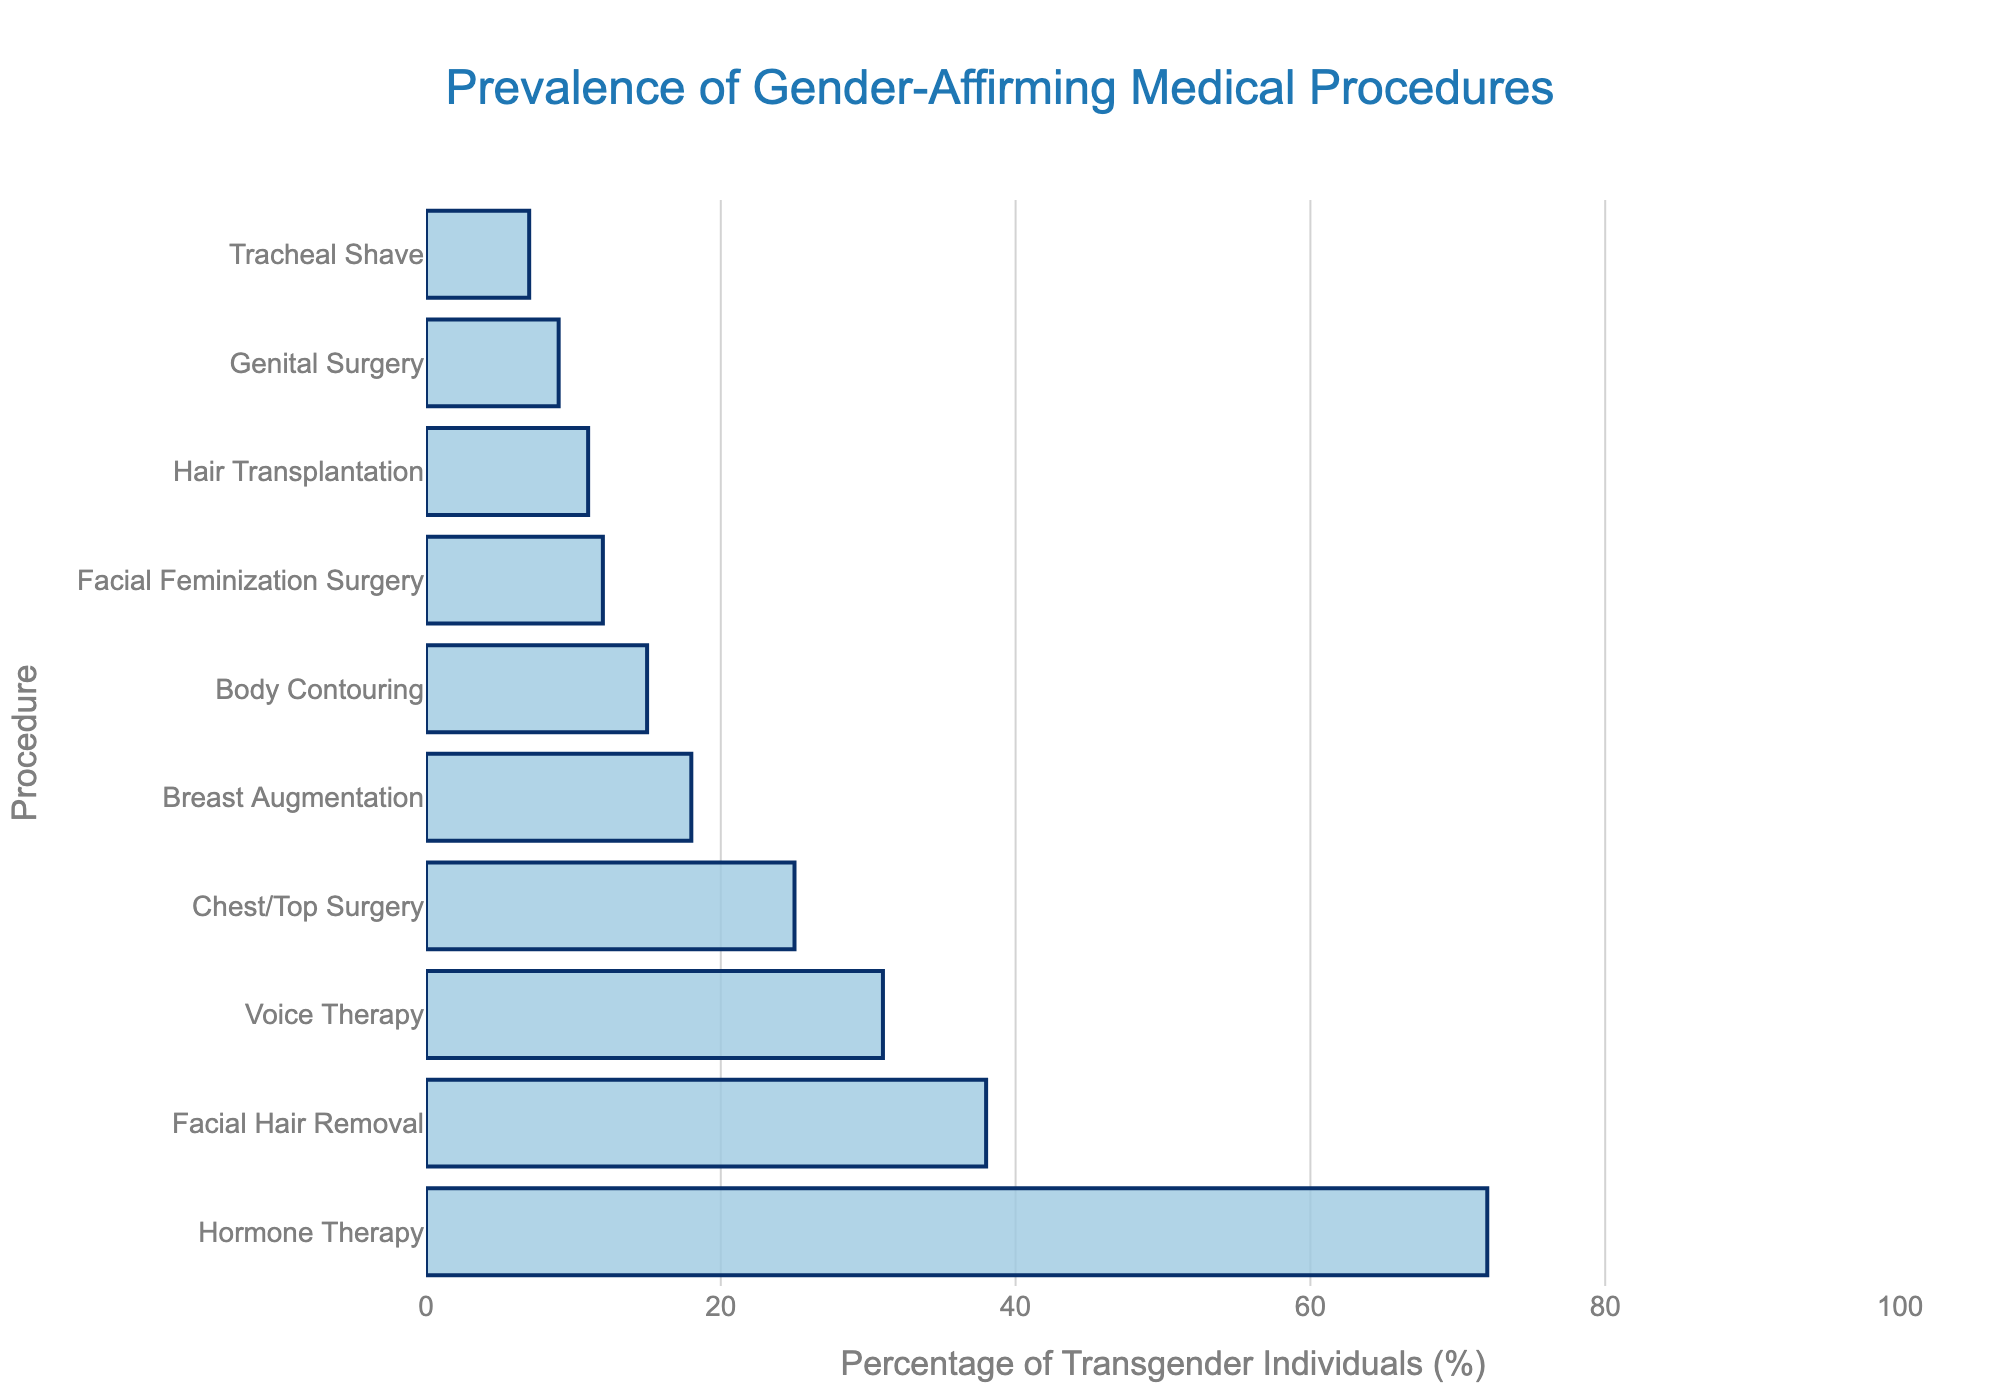What is the most common gender-affirming medical procedure according to the chart? The chart shows bars representing the percentage of transgender individuals undergoing various procedures. The longest bar represents the most common procedure. The longest bar belongs to Hormone Therapy at 72%.
Answer: Hormone Therapy Which procedure has a lower prevalence: Chest/Top Surgery or Breast Augmentation? By comparing the lengths of the bars representing Chest/Top Surgery and Breast Augmentation, Chest/Top Surgery is 25% and Breast Augmentation is 18%, so Breast Augmentation has a lower prevalence.
Answer: Breast Augmentation What is the combined percentage of transgender individuals who have undergone Facial Hair Removal and Voice Therapy? Add the percentages for Facial Hair Removal and Voice Therapy. Facial Hair Removal is 38% and Voice Therapy is 31%. The combined percentage is 38% + 31% = 69%.
Answer: 69% Among Tracheal Shave, Body Contouring, and Hair Transplantation, which procedure is the least prevalent? Comparing the lengths of the bars for Tracheal Shave (7%), Body Contouring (15%), and Hair Transplantation (11%), Tracheal Shave is the least prevalent.
Answer: Tracheal Shave How much higher is the prevalence of Hormone Therapy compared to Genital Surgery? Subtract the percentage of Genital Surgery from Hormone Therapy. Hormone Therapy is 72% and Genital Surgery is 9%, so the difference is 72% - 9% = 63%.
Answer: 63% What is the range of the percentages for all the procedures shown? The range is calculated by subtracting the smallest percentage from the largest. The smallest percentage is for Tracheal Shave at 7% and the largest is Hormone Therapy at 72%, so the range is 72% - 7% = 65%.
Answer: 65% How does the prevalence of Facial Feminization Surgery compare to Breast Augmentation? Comparing the percentages, Facial Feminization Surgery is 12% and Breast Augmentation is 18%. Since 12% is less than 18%, Facial Feminization Surgery has a lower prevalence.
Answer: Lower What is the median value of the percentages for all the procedures? To find the median, list the percentages in ascending order: 7, 9, 11, 12, 15, 18, 25, 31, 38, 72. The median is the average of the 5th and 6th values in this sorted list: (15 + 18) / 2 = 16.5.
Answer: 16.5 Which procedures have a prevalence between 10% and 20%? Identifying bars within this range, we find Breast Augmentation (18%), Body Contouring (15%), and Hair Transplantation (11%).
Answer: Breast Augmentation, Body Contouring, Hair Transplantation 